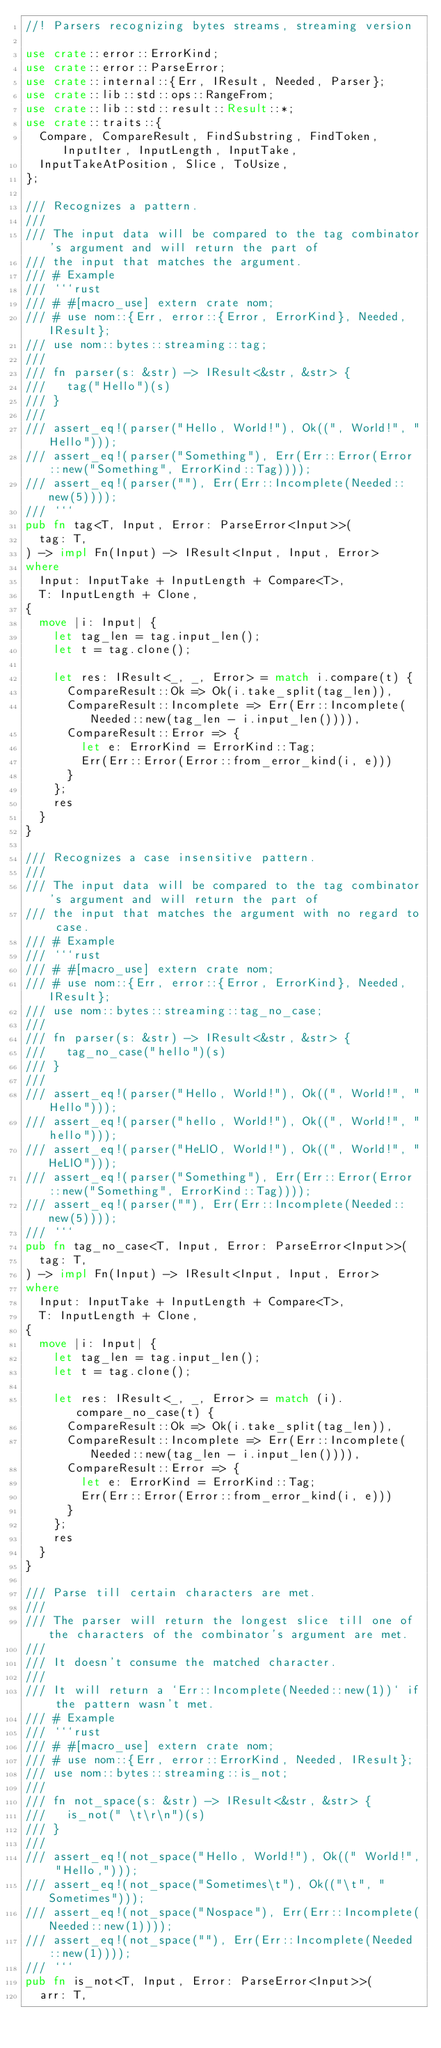<code> <loc_0><loc_0><loc_500><loc_500><_Rust_>//! Parsers recognizing bytes streams, streaming version

use crate::error::ErrorKind;
use crate::error::ParseError;
use crate::internal::{Err, IResult, Needed, Parser};
use crate::lib::std::ops::RangeFrom;
use crate::lib::std::result::Result::*;
use crate::traits::{
  Compare, CompareResult, FindSubstring, FindToken, InputIter, InputLength, InputTake,
  InputTakeAtPosition, Slice, ToUsize,
};

/// Recognizes a pattern.
///
/// The input data will be compared to the tag combinator's argument and will return the part of
/// the input that matches the argument.
/// # Example
/// ```rust
/// # #[macro_use] extern crate nom;
/// # use nom::{Err, error::{Error, ErrorKind}, Needed, IResult};
/// use nom::bytes::streaming::tag;
///
/// fn parser(s: &str) -> IResult<&str, &str> {
///   tag("Hello")(s)
/// }
///
/// assert_eq!(parser("Hello, World!"), Ok((", World!", "Hello")));
/// assert_eq!(parser("Something"), Err(Err::Error(Error::new("Something", ErrorKind::Tag))));
/// assert_eq!(parser(""), Err(Err::Incomplete(Needed::new(5))));
/// ```
pub fn tag<T, Input, Error: ParseError<Input>>(
  tag: T,
) -> impl Fn(Input) -> IResult<Input, Input, Error>
where
  Input: InputTake + InputLength + Compare<T>,
  T: InputLength + Clone,
{
  move |i: Input| {
    let tag_len = tag.input_len();
    let t = tag.clone();

    let res: IResult<_, _, Error> = match i.compare(t) {
      CompareResult::Ok => Ok(i.take_split(tag_len)),
      CompareResult::Incomplete => Err(Err::Incomplete(Needed::new(tag_len - i.input_len()))),
      CompareResult::Error => {
        let e: ErrorKind = ErrorKind::Tag;
        Err(Err::Error(Error::from_error_kind(i, e)))
      }
    };
    res
  }
}

/// Recognizes a case insensitive pattern.
///
/// The input data will be compared to the tag combinator's argument and will return the part of
/// the input that matches the argument with no regard to case.
/// # Example
/// ```rust
/// # #[macro_use] extern crate nom;
/// # use nom::{Err, error::{Error, ErrorKind}, Needed, IResult};
/// use nom::bytes::streaming::tag_no_case;
///
/// fn parser(s: &str) -> IResult<&str, &str> {
///   tag_no_case("hello")(s)
/// }
///
/// assert_eq!(parser("Hello, World!"), Ok((", World!", "Hello")));
/// assert_eq!(parser("hello, World!"), Ok((", World!", "hello")));
/// assert_eq!(parser("HeLlO, World!"), Ok((", World!", "HeLlO")));
/// assert_eq!(parser("Something"), Err(Err::Error(Error::new("Something", ErrorKind::Tag))));
/// assert_eq!(parser(""), Err(Err::Incomplete(Needed::new(5))));
/// ```
pub fn tag_no_case<T, Input, Error: ParseError<Input>>(
  tag: T,
) -> impl Fn(Input) -> IResult<Input, Input, Error>
where
  Input: InputTake + InputLength + Compare<T>,
  T: InputLength + Clone,
{
  move |i: Input| {
    let tag_len = tag.input_len();
    let t = tag.clone();

    let res: IResult<_, _, Error> = match (i).compare_no_case(t) {
      CompareResult::Ok => Ok(i.take_split(tag_len)),
      CompareResult::Incomplete => Err(Err::Incomplete(Needed::new(tag_len - i.input_len()))),
      CompareResult::Error => {
        let e: ErrorKind = ErrorKind::Tag;
        Err(Err::Error(Error::from_error_kind(i, e)))
      }
    };
    res
  }
}

/// Parse till certain characters are met.
///
/// The parser will return the longest slice till one of the characters of the combinator's argument are met.
///
/// It doesn't consume the matched character.
///
/// It will return a `Err::Incomplete(Needed::new(1))` if the pattern wasn't met.
/// # Example
/// ```rust
/// # #[macro_use] extern crate nom;
/// # use nom::{Err, error::ErrorKind, Needed, IResult};
/// use nom::bytes::streaming::is_not;
///
/// fn not_space(s: &str) -> IResult<&str, &str> {
///   is_not(" \t\r\n")(s)
/// }
///
/// assert_eq!(not_space("Hello, World!"), Ok((" World!", "Hello,")));
/// assert_eq!(not_space("Sometimes\t"), Ok(("\t", "Sometimes")));
/// assert_eq!(not_space("Nospace"), Err(Err::Incomplete(Needed::new(1))));
/// assert_eq!(not_space(""), Err(Err::Incomplete(Needed::new(1))));
/// ```
pub fn is_not<T, Input, Error: ParseError<Input>>(
  arr: T,</code> 